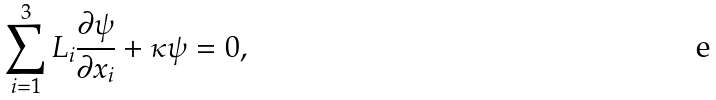<formula> <loc_0><loc_0><loc_500><loc_500>\sum ^ { 3 } _ { i = 1 } L _ { i } \frac { \partial \psi } { \partial x _ { i } } + \kappa \psi = 0 ,</formula> 